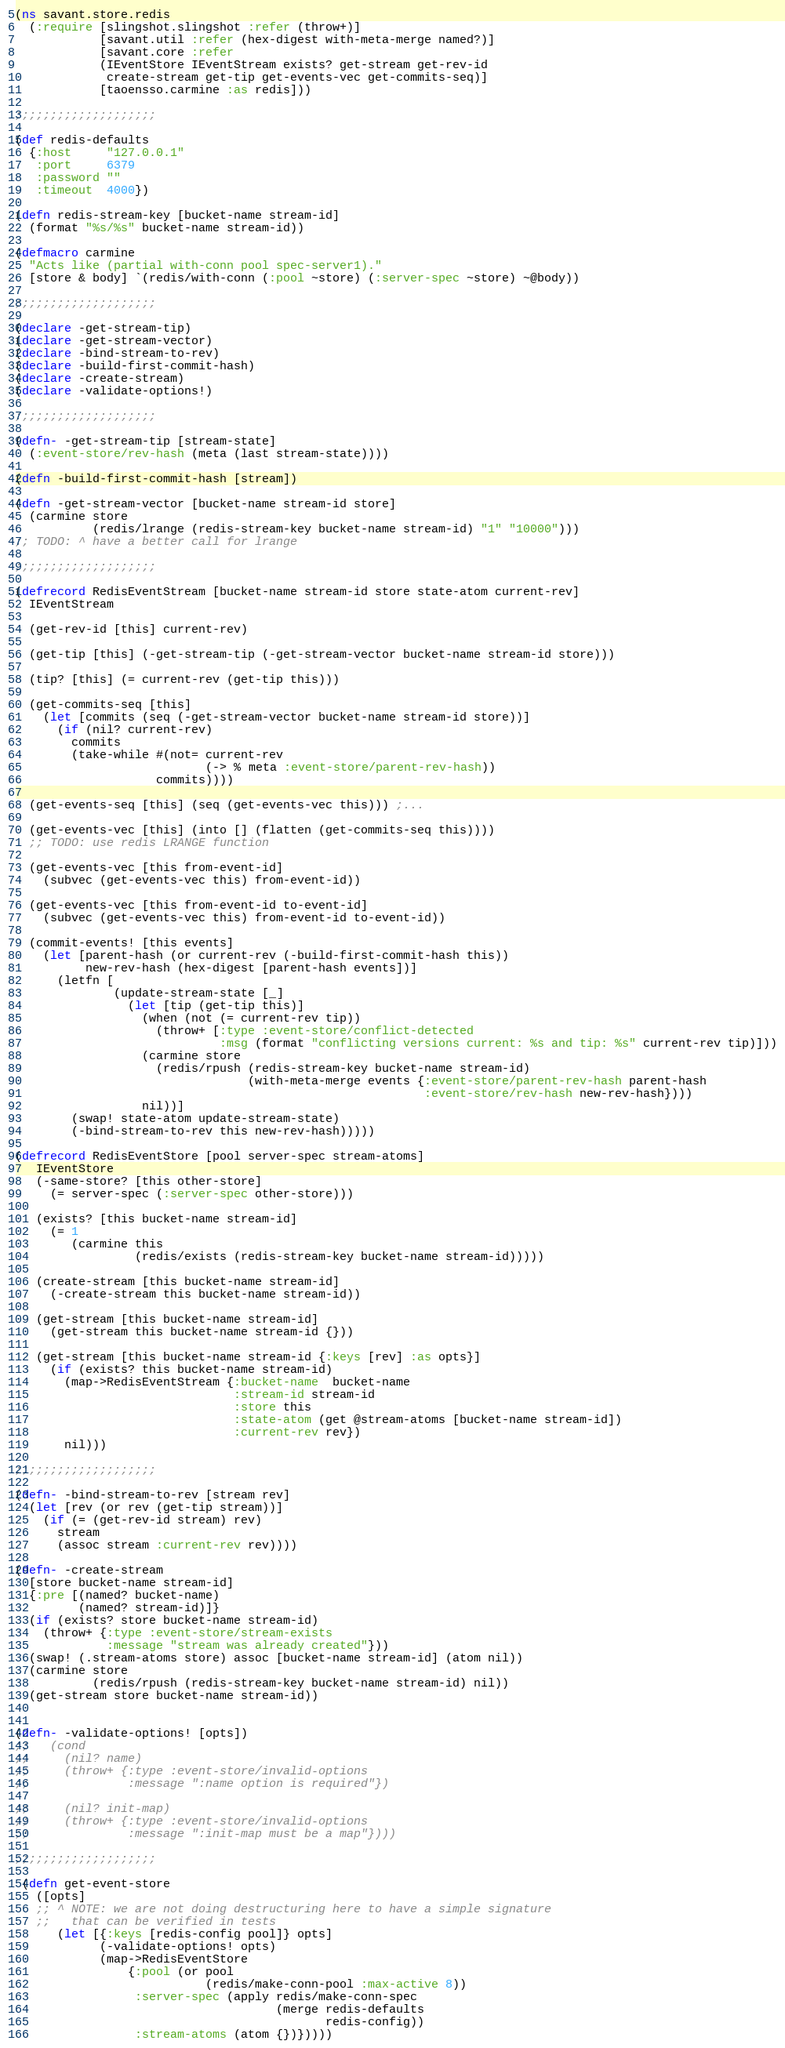Convert code to text. <code><loc_0><loc_0><loc_500><loc_500><_Clojure_>(ns savant.store.redis
  (:require [slingshot.slingshot :refer (throw+)]
            [savant.util :refer (hex-digest with-meta-merge named?)]
            [savant.core :refer
            (IEventStore IEventStream exists? get-stream get-rev-id
             create-stream get-tip get-events-vec get-commits-seq)]
            [taoensso.carmine :as redis]))

;;;;;;;;;;;;;;;;;;;;

(def redis-defaults
  {:host     "127.0.0.1"
   :port     6379
   :password ""
   :timeout  4000})

(defn redis-stream-key [bucket-name stream-id]
  (format "%s/%s" bucket-name stream-id))

(defmacro carmine
  "Acts like (partial with-conn pool spec-server1)."
  [store & body] `(redis/with-conn (:pool ~store) (:server-spec ~store) ~@body))

;;;;;;;;;;;;;;;;;;;;

(declare -get-stream-tip)
(declare -get-stream-vector)
(declare -bind-stream-to-rev)
(declare -build-first-commit-hash)
(declare -create-stream)
(declare -validate-options!)

;;;;;;;;;;;;;;;;;;;;

(defn- -get-stream-tip [stream-state]
  (:event-store/rev-hash (meta (last stream-state))))

(defn -build-first-commit-hash [stream])

(defn -get-stream-vector [bucket-name stream-id store]
  (carmine store
           (redis/lrange (redis-stream-key bucket-name stream-id) "1" "10000")))
;; TODO: ^ have a better call for lrange

;;;;;;;;;;;;;;;;;;;;

(defrecord RedisEventStream [bucket-name stream-id store state-atom current-rev]
  IEventStream

  (get-rev-id [this] current-rev)

  (get-tip [this] (-get-stream-tip (-get-stream-vector bucket-name stream-id store)))

  (tip? [this] (= current-rev (get-tip this)))

  (get-commits-seq [this]
    (let [commits (seq (-get-stream-vector bucket-name stream-id store))]
      (if (nil? current-rev)
        commits
        (take-while #(not= current-rev
                           (-> % meta :event-store/parent-rev-hash))
                    commits))))

  (get-events-seq [this] (seq (get-events-vec this))) ;...

  (get-events-vec [this] (into [] (flatten (get-commits-seq this))))
  ;; TODO: use redis LRANGE function

  (get-events-vec [this from-event-id]
    (subvec (get-events-vec this) from-event-id))

  (get-events-vec [this from-event-id to-event-id]
    (subvec (get-events-vec this) from-event-id to-event-id))

  (commit-events! [this events]
    (let [parent-hash (or current-rev (-build-first-commit-hash this))
          new-rev-hash (hex-digest [parent-hash events])]
      (letfn [
              (update-stream-state [_]
                (let [tip (get-tip this)]
                  (when (not (= current-rev tip))
                    (throw+ [:type :event-store/conflict-detected
                             :msg (format "conflicting versions current: %s and tip: %s" current-rev tip)]))
                  (carmine store
                    (redis/rpush (redis-stream-key bucket-name stream-id)
                                 (with-meta-merge events {:event-store/parent-rev-hash parent-hash
                                                          :event-store/rev-hash new-rev-hash})))
                  nil))]
        (swap! state-atom update-stream-state)
        (-bind-stream-to-rev this new-rev-hash)))))

(defrecord RedisEventStore [pool server-spec stream-atoms]
   IEventStore
   (-same-store? [this other-store]
     (= server-spec (:server-spec other-store)))

   (exists? [this bucket-name stream-id]
     (= 1
        (carmine this
                 (redis/exists (redis-stream-key bucket-name stream-id)))))

   (create-stream [this bucket-name stream-id]
     (-create-stream this bucket-name stream-id))

   (get-stream [this bucket-name stream-id]
     (get-stream this bucket-name stream-id {}))

   (get-stream [this bucket-name stream-id {:keys [rev] :as opts}]
     (if (exists? this bucket-name stream-id)
       (map->RedisEventStream {:bucket-name  bucket-name
                               :stream-id stream-id
                               :store this
                               :state-atom (get @stream-atoms [bucket-name stream-id])
                               :current-rev rev})
       nil)))

;;;;;;;;;;;;;;;;;;;;

(defn- -bind-stream-to-rev [stream rev]
  (let [rev (or rev (get-tip stream))]
    (if (= (get-rev-id stream) rev)
      stream
      (assoc stream :current-rev rev))))

(defn- -create-stream
  [store bucket-name stream-id]
  {:pre [(named? bucket-name)
         (named? stream-id)]}
  (if (exists? store bucket-name stream-id)
    (throw+ {:type :event-store/stream-exists
             :message "stream was already created"}))
  (swap! (.stream-atoms store) assoc [bucket-name stream-id] (atom nil))
  (carmine store
           (redis/rpush (redis-stream-key bucket-name stream-id) nil))
  (get-stream store bucket-name stream-id))


(defn- -validate-options! [opts])
;;   (cond
;;     (nil? name)
;;     (throw+ {:type :event-store/invalid-options
;;              :message ":name option is required"})

;;     (nil? init-map)
;;     (throw+ {:type :event-store/invalid-options
;;              :message ":init-map must be a map"})))

;;;;;;;;;;;;;;;;;;;;

 (defn get-event-store
   ([opts]
   ;; ^ NOTE: we are not doing destructuring here to have a simple signature
   ;;   that can be verified in tests
      (let [{:keys [redis-config pool]} opts]
            (-validate-options! opts)
            (map->RedisEventStore
                {:pool (or pool
                           (redis/make-conn-pool :max-active 8))
                 :server-spec (apply redis/make-conn-spec
                                     (merge redis-defaults
                                            redis-config))
                 :stream-atoms (atom {})}))))
</code> 